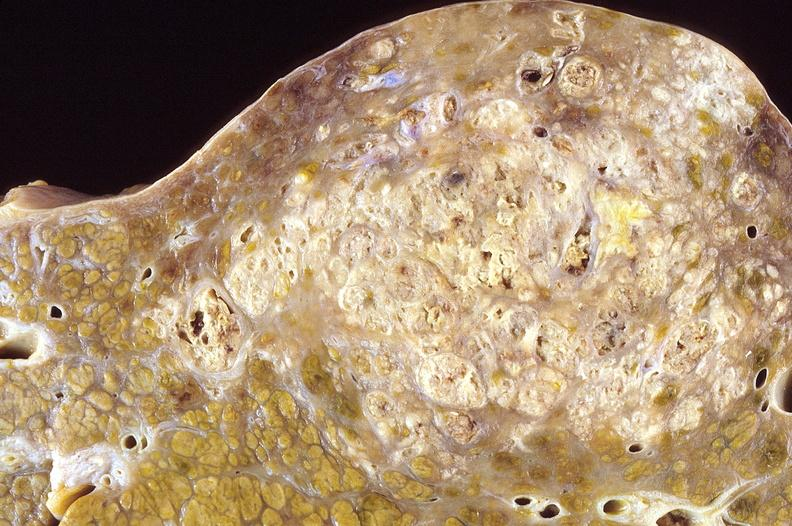does serous cystadenoma show hepatocellular carcinoma, hepatitis c positive?
Answer the question using a single word or phrase. No 